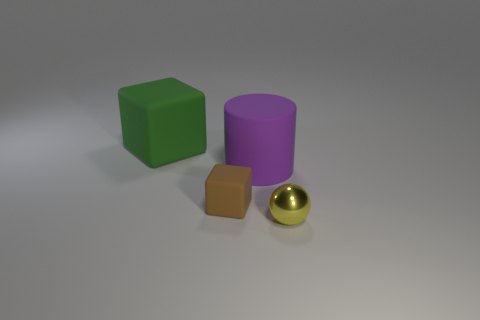Add 1 brown things. How many objects exist? 5 Subtract all cylinders. How many objects are left? 3 Subtract 0 blue blocks. How many objects are left? 4 Subtract all purple cylinders. Subtract all matte things. How many objects are left? 0 Add 4 shiny objects. How many shiny objects are left? 5 Add 4 large rubber cylinders. How many large rubber cylinders exist? 5 